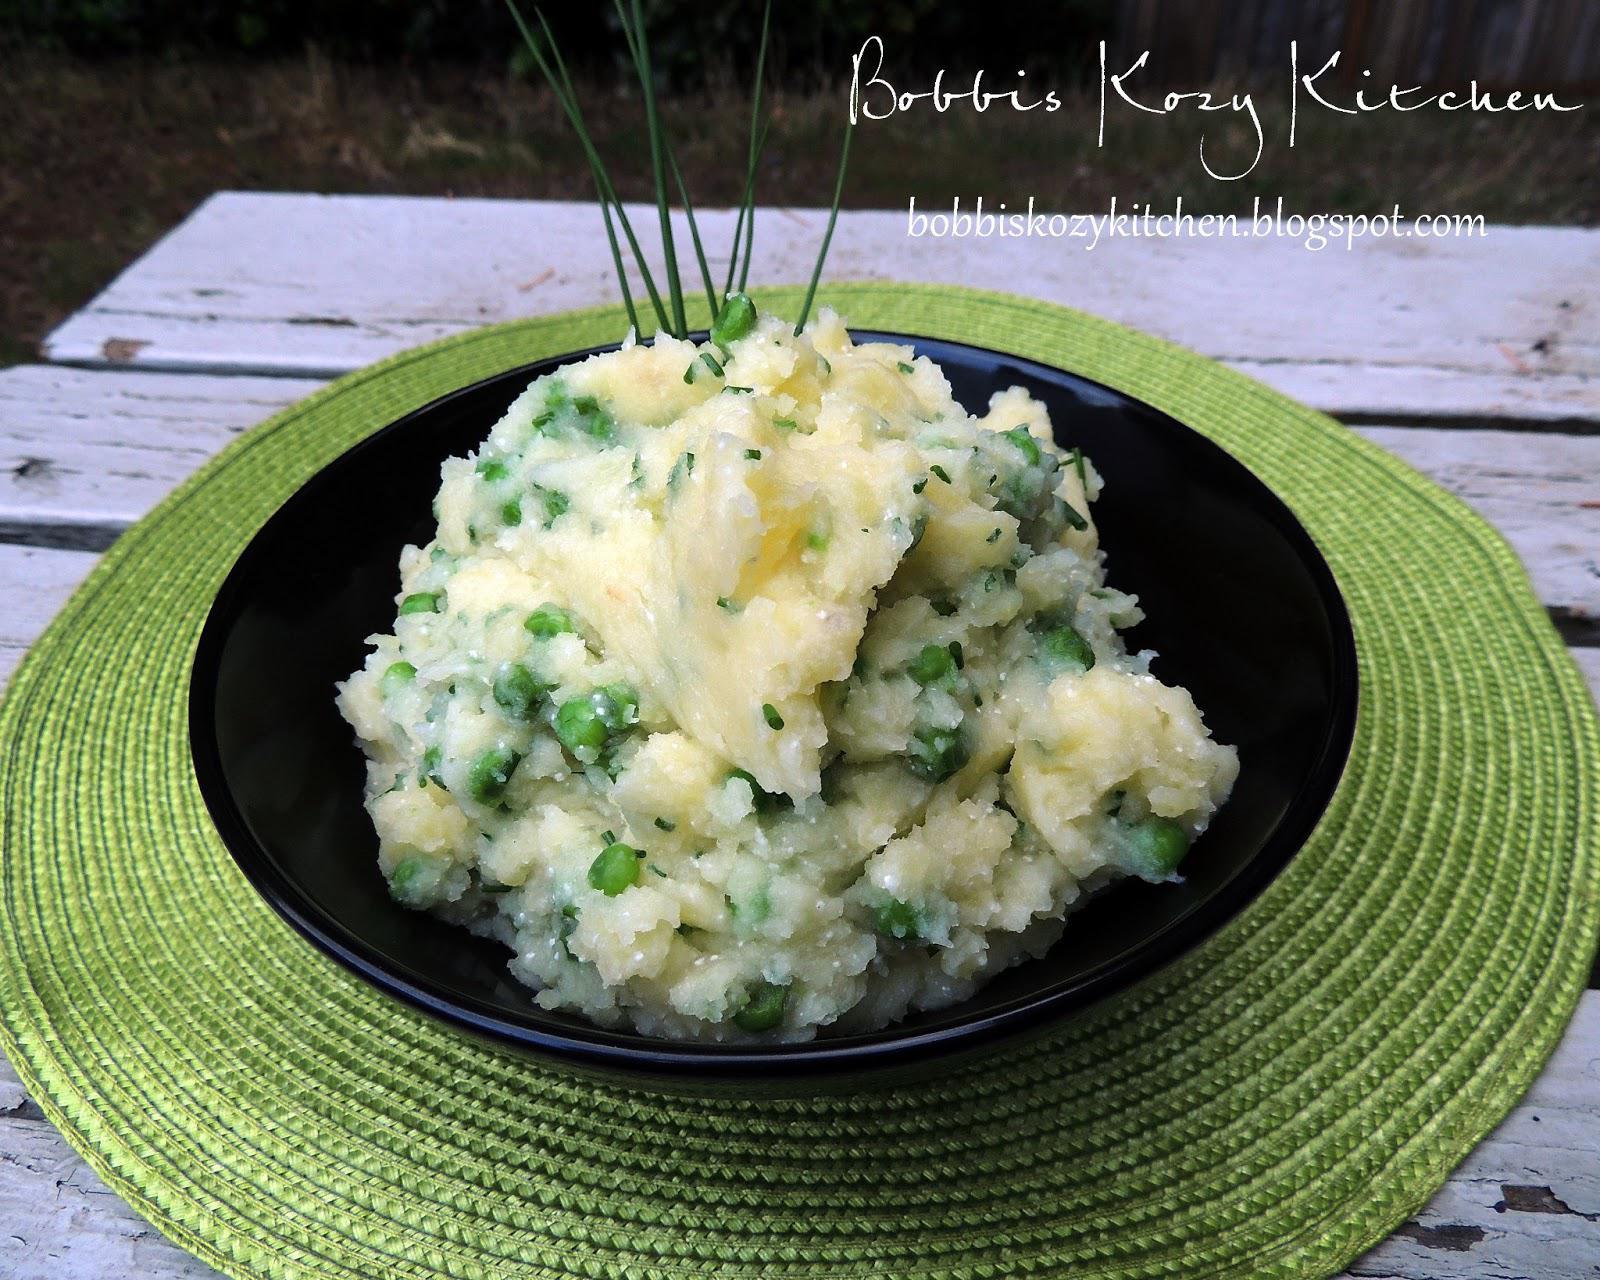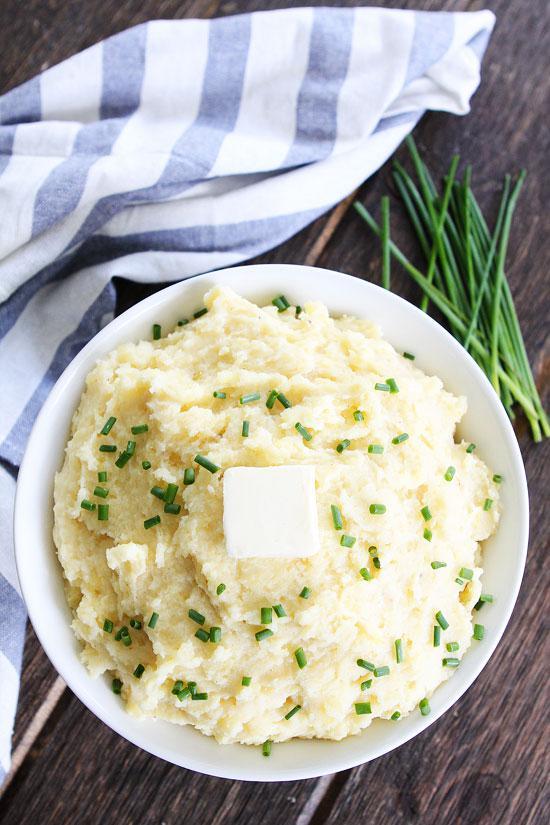The first image is the image on the left, the second image is the image on the right. Given the left and right images, does the statement "In one image a round white bowl of mashed potatoes is garnished with chives, while a second image shows mashed potatoes with a green garnish served in a dark dish." hold true? Answer yes or no. Yes. The first image is the image on the left, the second image is the image on the right. Considering the images on both sides, is "An image shows a round container of food with green peas in a pile on the very top." valid? Answer yes or no. No. 